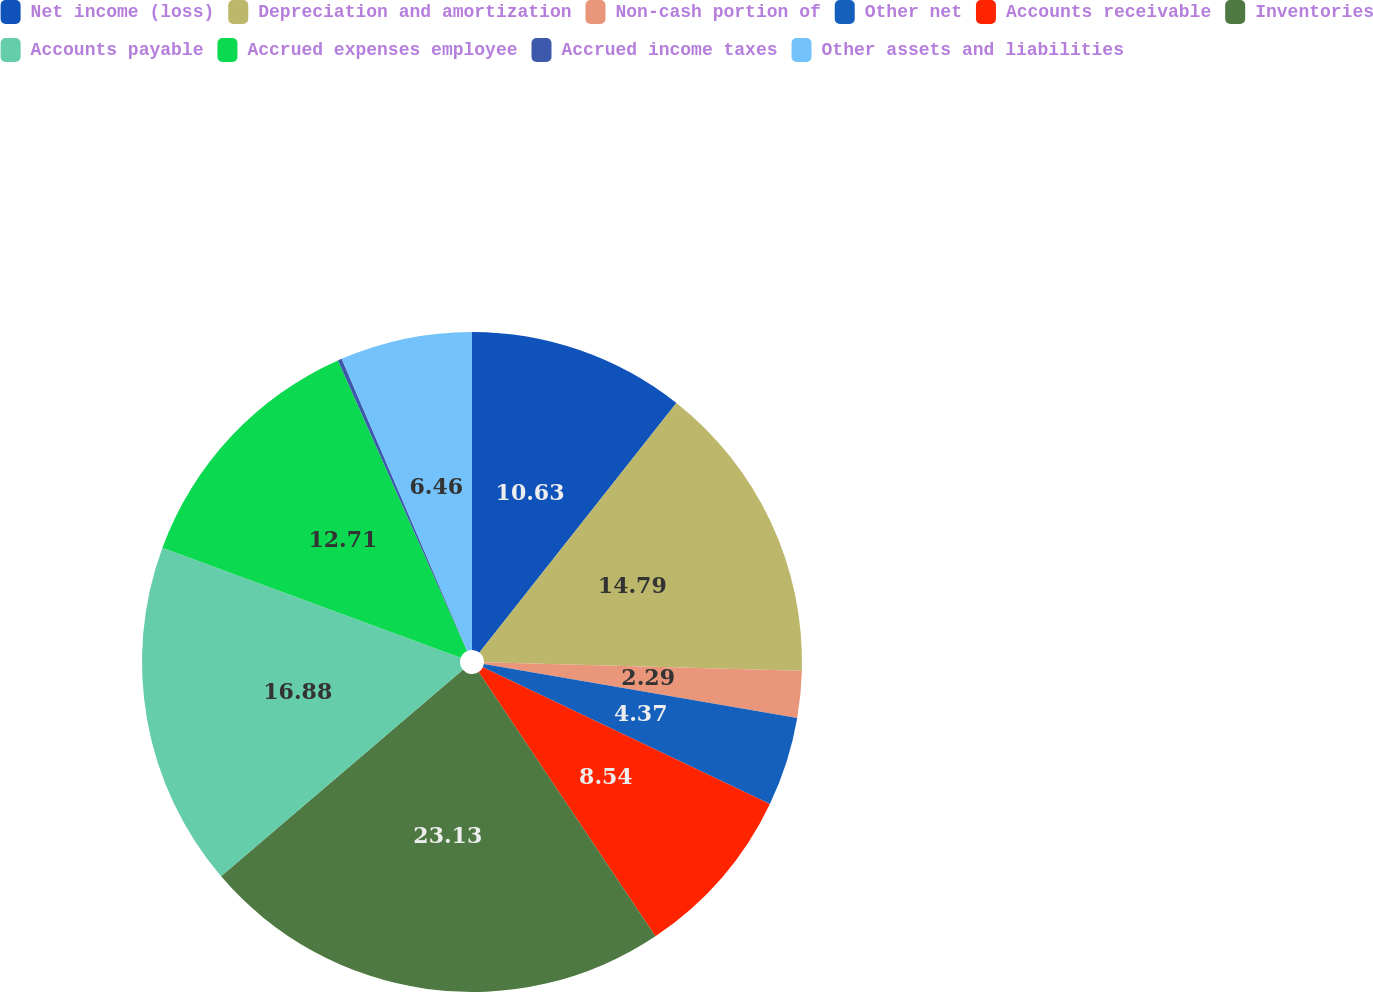<chart> <loc_0><loc_0><loc_500><loc_500><pie_chart><fcel>Net income (loss)<fcel>Depreciation and amortization<fcel>Non-cash portion of<fcel>Other net<fcel>Accounts receivable<fcel>Inventories<fcel>Accounts payable<fcel>Accrued expenses employee<fcel>Accrued income taxes<fcel>Other assets and liabilities<nl><fcel>10.63%<fcel>14.79%<fcel>2.29%<fcel>4.37%<fcel>8.54%<fcel>23.13%<fcel>16.88%<fcel>12.71%<fcel>0.2%<fcel>6.46%<nl></chart> 